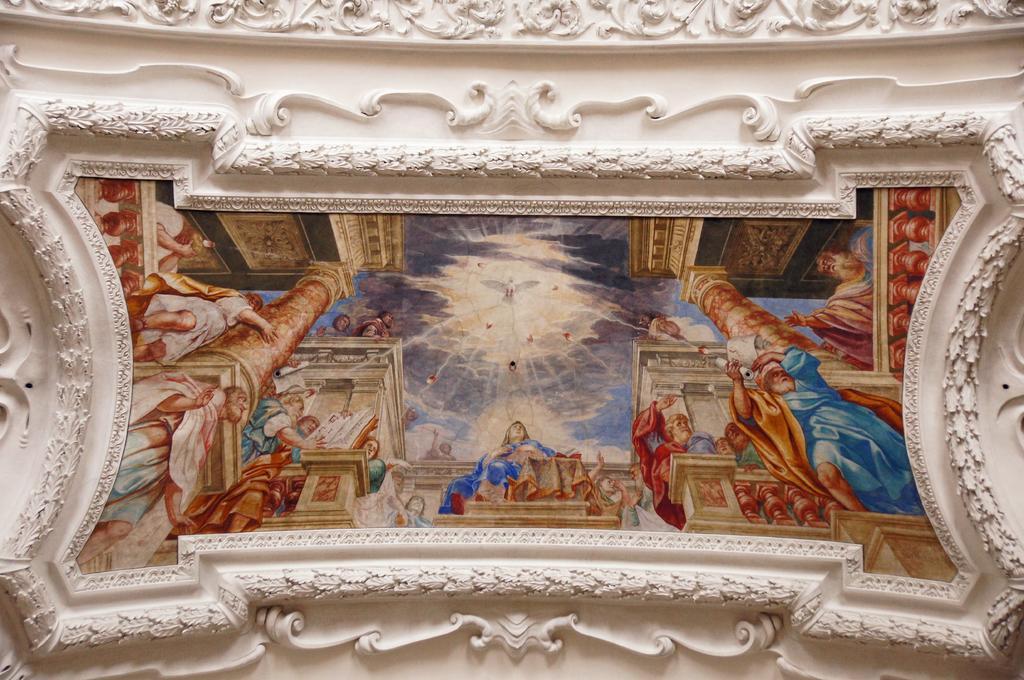How would you summarize this image in a sentence or two? In this image there is a wall and we can see a photo frame placed on the wall. We can see carvings on the wall. 